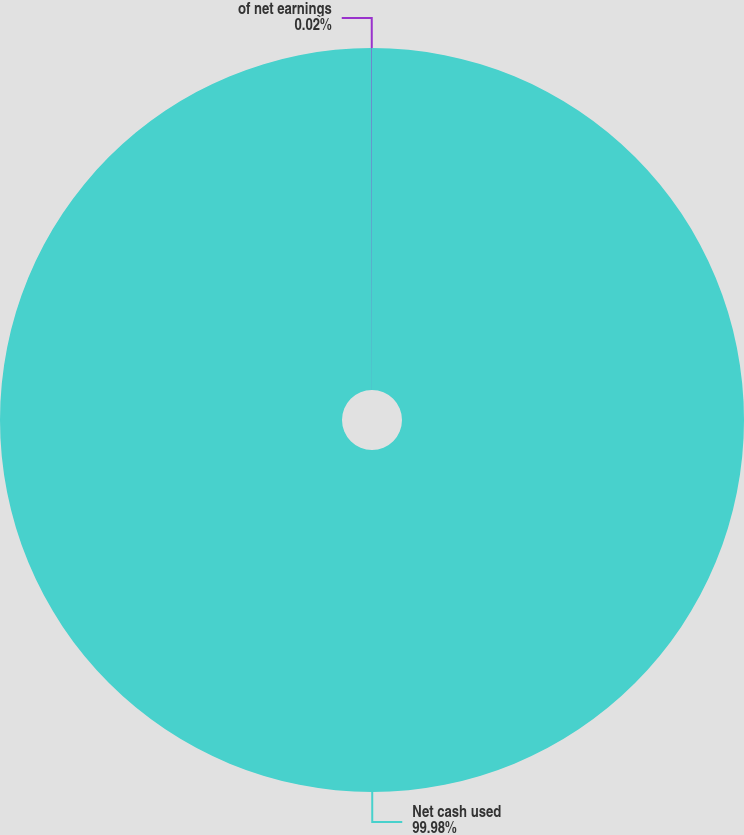<chart> <loc_0><loc_0><loc_500><loc_500><pie_chart><fcel>Net cash used<fcel>of net earnings<nl><fcel>99.98%<fcel>0.02%<nl></chart> 